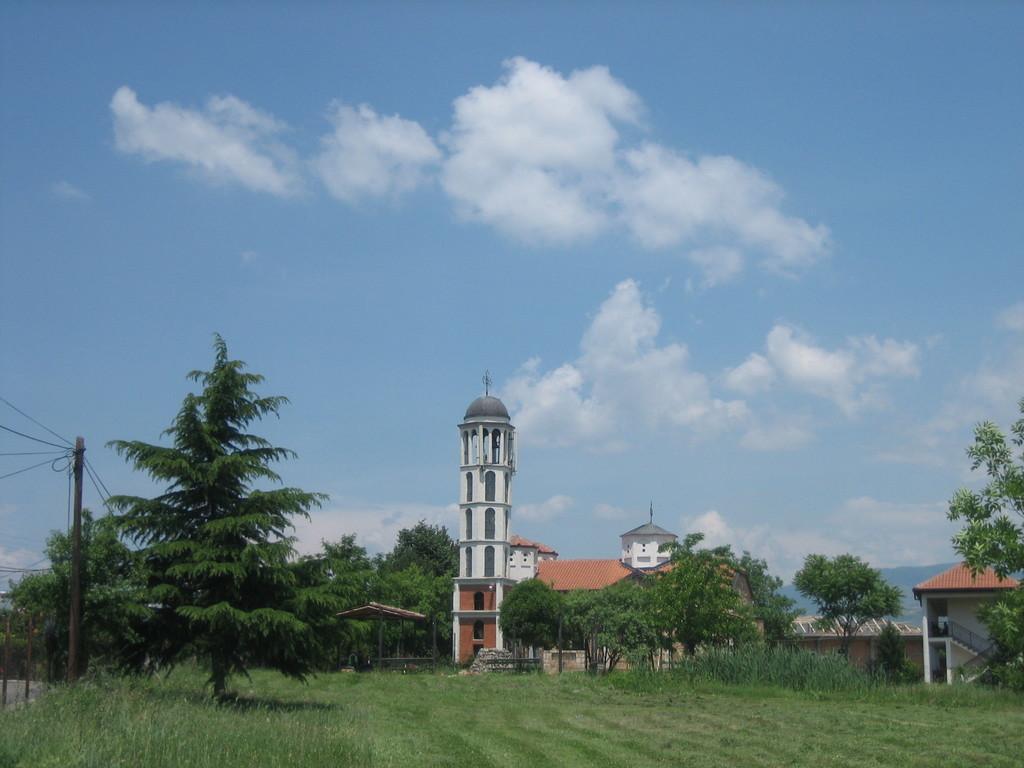How would you summarize this image in a sentence or two? In this picture we can see the grass, poles, trees, buildings, wires and in the background we can see the sky with clouds. 